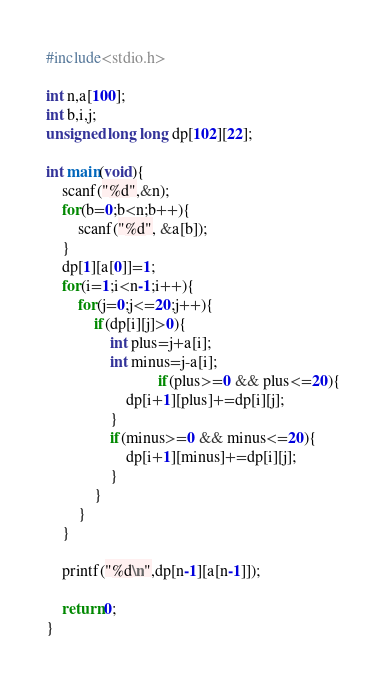<code> <loc_0><loc_0><loc_500><loc_500><_C_>#include<stdio.h>

int n,a[100];
int b,i,j;
unsigned long long dp[102][22];

int main(void){
	scanf("%d",&n);
	for(b=0;b<n;b++){
		scanf("%d", &a[b]);
	}
	dp[1][a[0]]=1;
	for(i=1;i<n-1;i++){
		for(j=0;j<=20;j++){
			if(dp[i][j]>0){
				int plus=j+a[i];
				int minus=j-a[i];
        	                if(plus>=0 && plus<=20){
					dp[i+1][plus]+=dp[i][j];
				}
				if(minus>=0 && minus<=20){
					dp[i+1][minus]+=dp[i][j];
				}
			}
		}
	}
	
	printf("%d\n",dp[n-1][a[n-1]]);

	return 0;
}</code> 